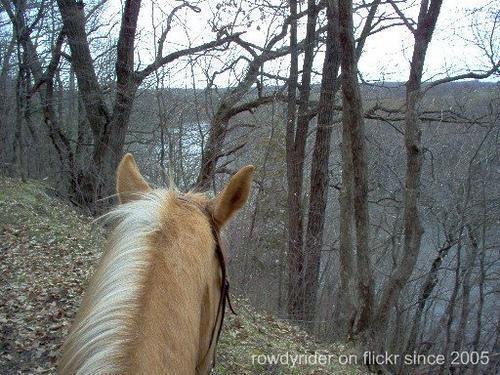How many horses are there?
Give a very brief answer. 1. 